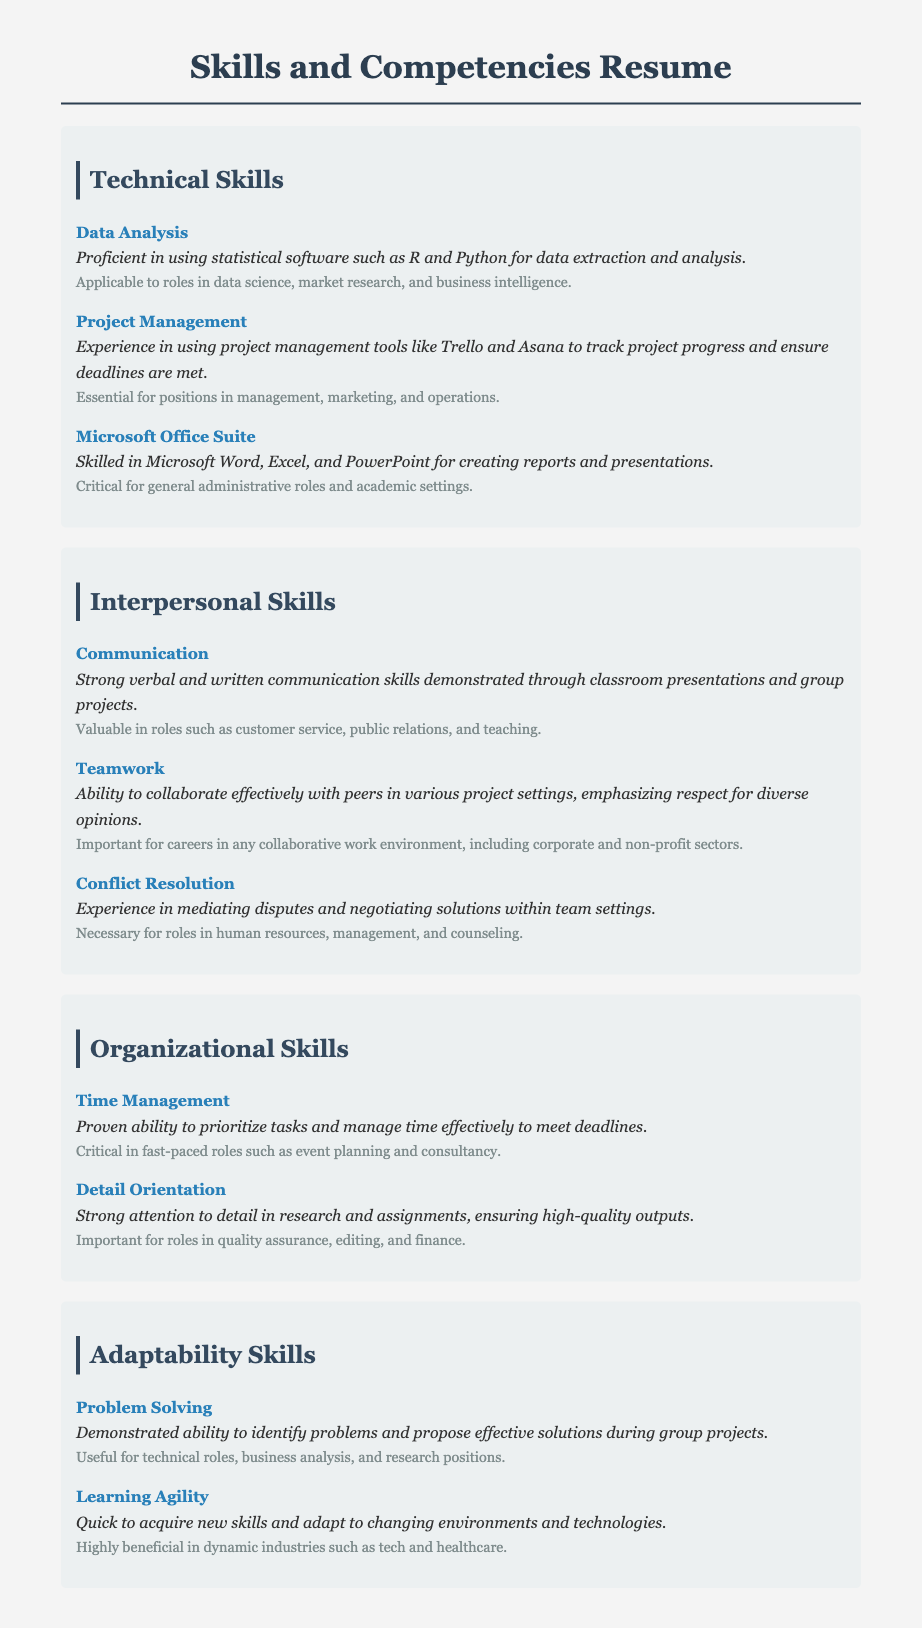What is the total number of technical skills listed? The document lists three technical skills: Data Analysis, Project Management, and Microsoft Office Suite.
Answer: 3 Which software is mentioned for Data Analysis? The document specifies that R and Python are the statistical software used for data analysis.
Answer: R and Python What interpersonal skill is emphasized for customer service roles? The document states that strong verbal and written communication skills are valuable in customer service roles.
Answer: Communication What is the relevance of Time Management skills? The document suggests that Time Management is critical in fast-paced roles such as event planning and consultancy.
Answer: Critical in fast-paced roles Which skill is important for quality assurance roles? The document highlights Detail Orientation as important for roles in quality assurance.
Answer: Detail Orientation How many adaptability skills are listed? There are two adaptability skills mentioned: Problem Solving and Learning Agility.
Answer: 2 What project management tools are mentioned? The document lists Trello and Asana as the project management tools used.
Answer: Trello and Asana Which soft skill involves mediating disputes? The document lists Conflict Resolution as the skill involved in mediating disputes.
Answer: Conflict Resolution What is the significance of Learning Agility in dynamic industries? The document mentions that Learning Agility is highly beneficial in dynamic industries such as tech and healthcare.
Answer: Highly beneficial in dynamic industries 